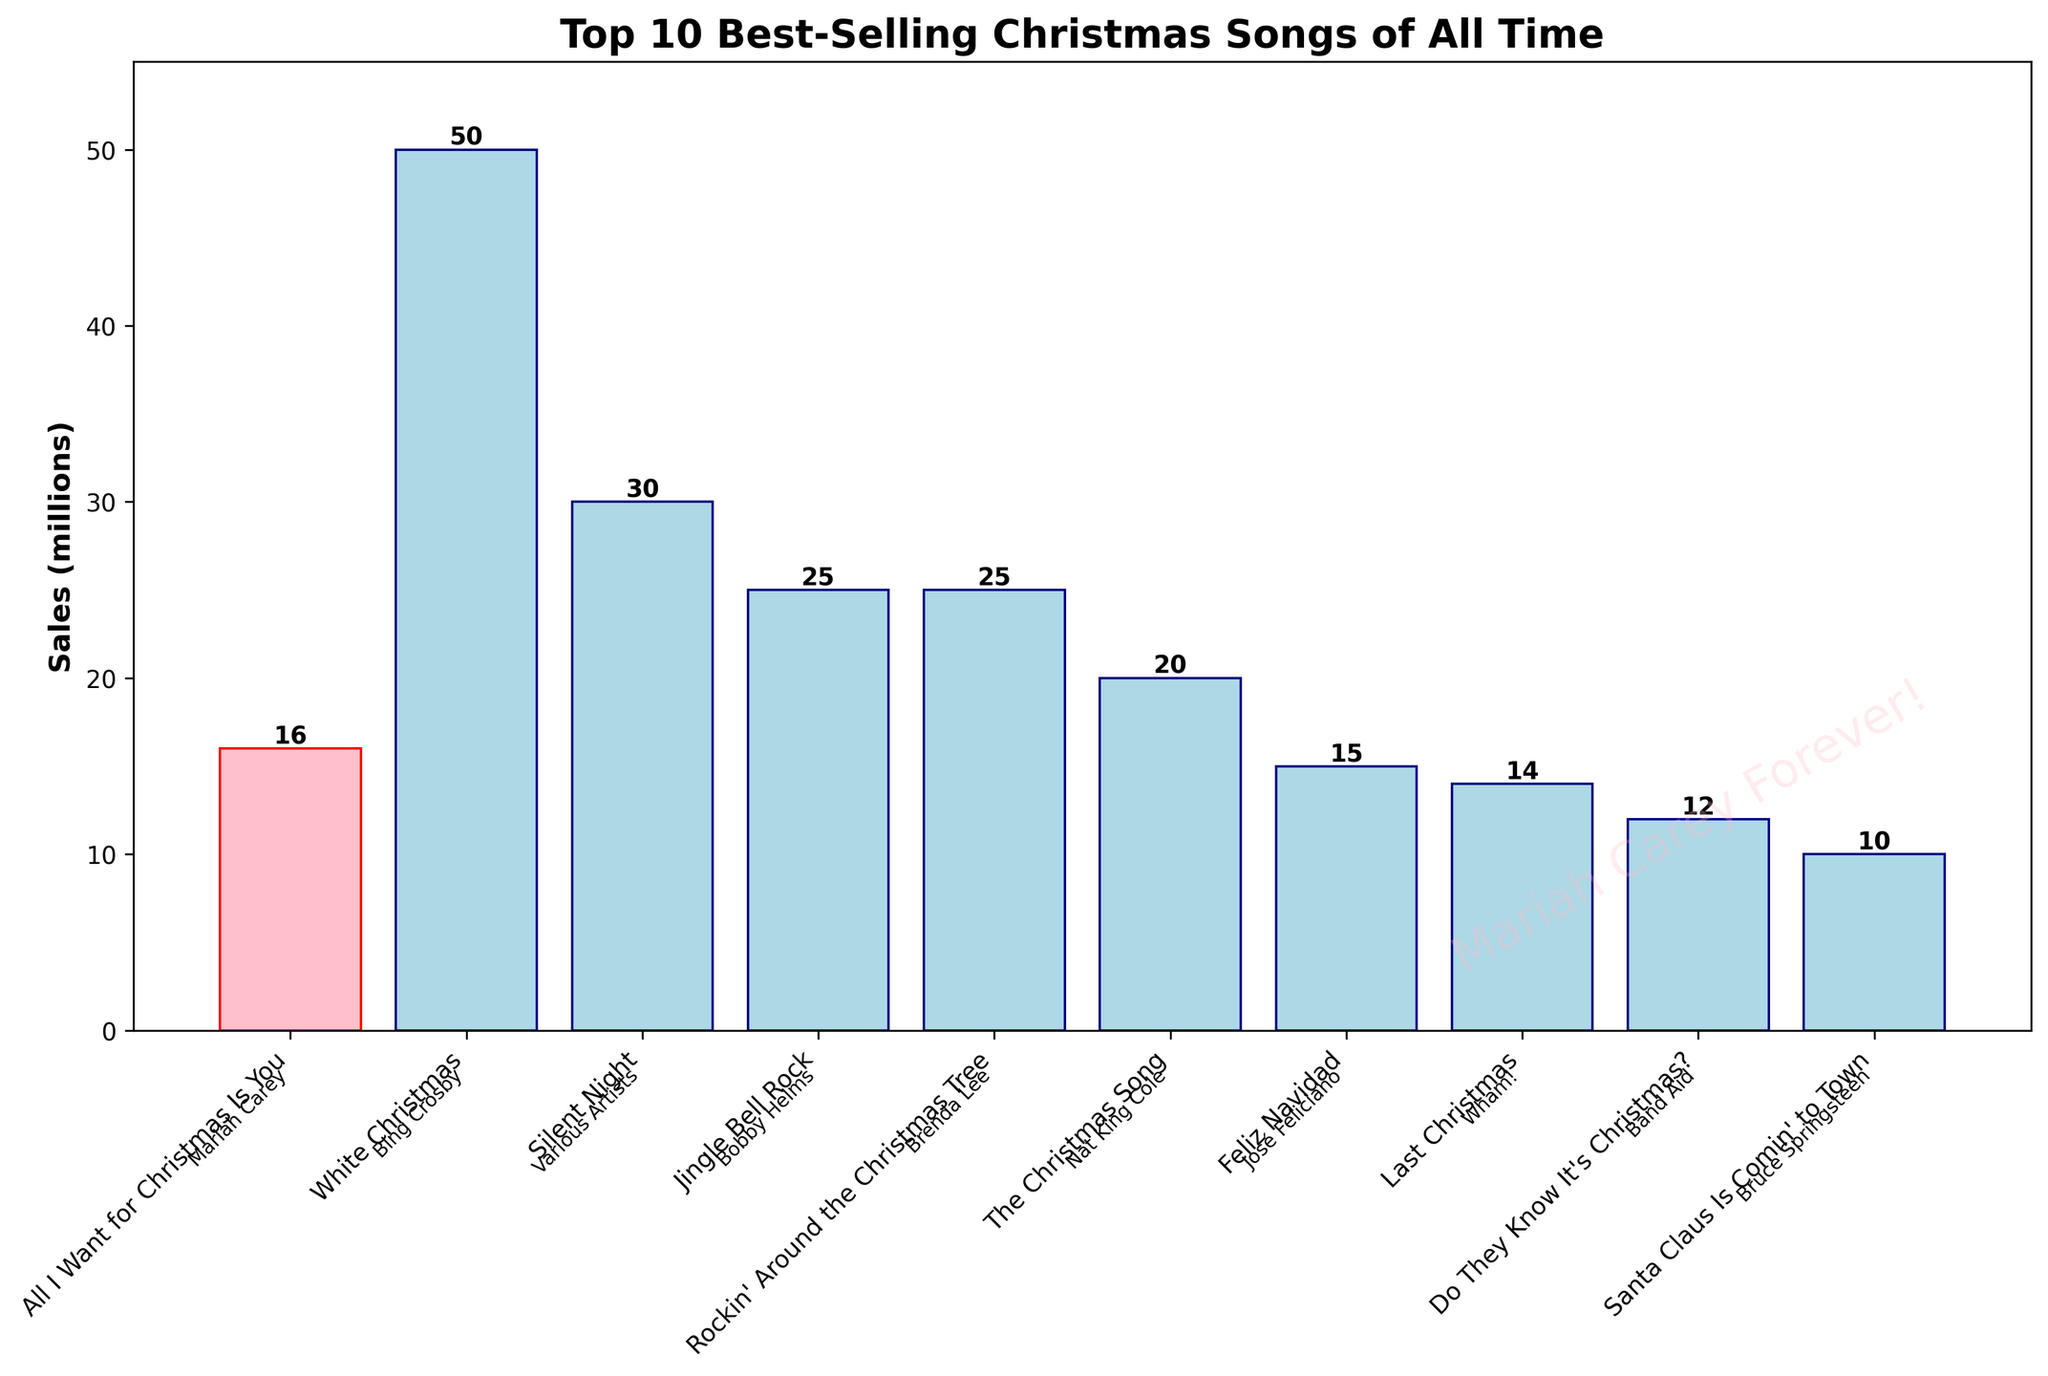Which song is the best-selling Christmas song of all time? The bar chart shows each song's sales in millions. The tallest bar represents "White Christmas" by Bing Crosby, with 50 million sales.
Answer: "White Christmas" - Bing Crosby How many millions of sales does "All I Want for Christmas Is You" by Mariah Carey have? By looking at the bar highlighted in pink, which represents Mariah Carey's song, we see that it reaches the 16 million mark.
Answer: 16 million Comparing "All I Want for Christmas Is You" by Mariah Carey and "Jingle Bell Rock" by Bobby Helms, which song has more sales, and by how much? "Jingle Bell Rock" by Bobby Helms has 25 million sales, while Mariah Carey's song has 16 million. The difference is 25 - 16 = 9 million.
Answer: "Jingle Bell Rock" by Bobby Helms by 9 million How do the sales of "Rockin' Around the Christmas Tree" by Brenda Lee compare to "Last Christmas" by Wham!? "Rockin' Around the Christmas Tree" has 25 million sales, and "Last Christmas" has 14 million sales. Brenda Lee's song has 25 - 14 = 11 million more sales.
Answer: "Rockin' Around the Christmas Tree" by 11 million Which song has the least sales, and how many millions? By identifying the shortest bar in the chart, we see that "Santa Claus Is Comin' to Town" by Bruce Springsteen has the least sales with 10 million.
Answer: "Santa Claus Is Comin' to Town" - Bruce Springsteen, 10 million What is the total sales of all top 10 best-selling Christmas songs? Add up all the sales: 50 + 30 + 25 + 25 + 20 + 16 + 15 + 14 + 12 + 10 = 217 million.
Answer: 217 million Considering "Silent Night" and "White Christmas," what is their combined sales figure? "Silent Night" has 30 million sales, and "White Christmas" has 50 million. Their combined sales are 30 + 50 = 80 million.
Answer: 80 million What is the average sales figure for these top 10 Christmas songs? Total sales are 217 million. There are 10 songs. The average sales are 217 / 10 = 21.7 million.
Answer: 21.7 million How does the number of sales of "Feliz Navidad" by José Feliciano compare to the average sales figure? "Feliz Navidad" has 15 million sales. The average is 21.7 million. 21.7 - 15 = 6.7 million below the average.
Answer: 6.7 million below average Which song by an artist other than Mariah Carey is closest in sales to "All I Want for Christmas Is You"? "All I Want for Christmas Is You" has 16 million sales. The closest in sales is "Feliz Navidad" by José Feliciano, with 15 million.
Answer: "Feliz Navidad" - José Feliciano 